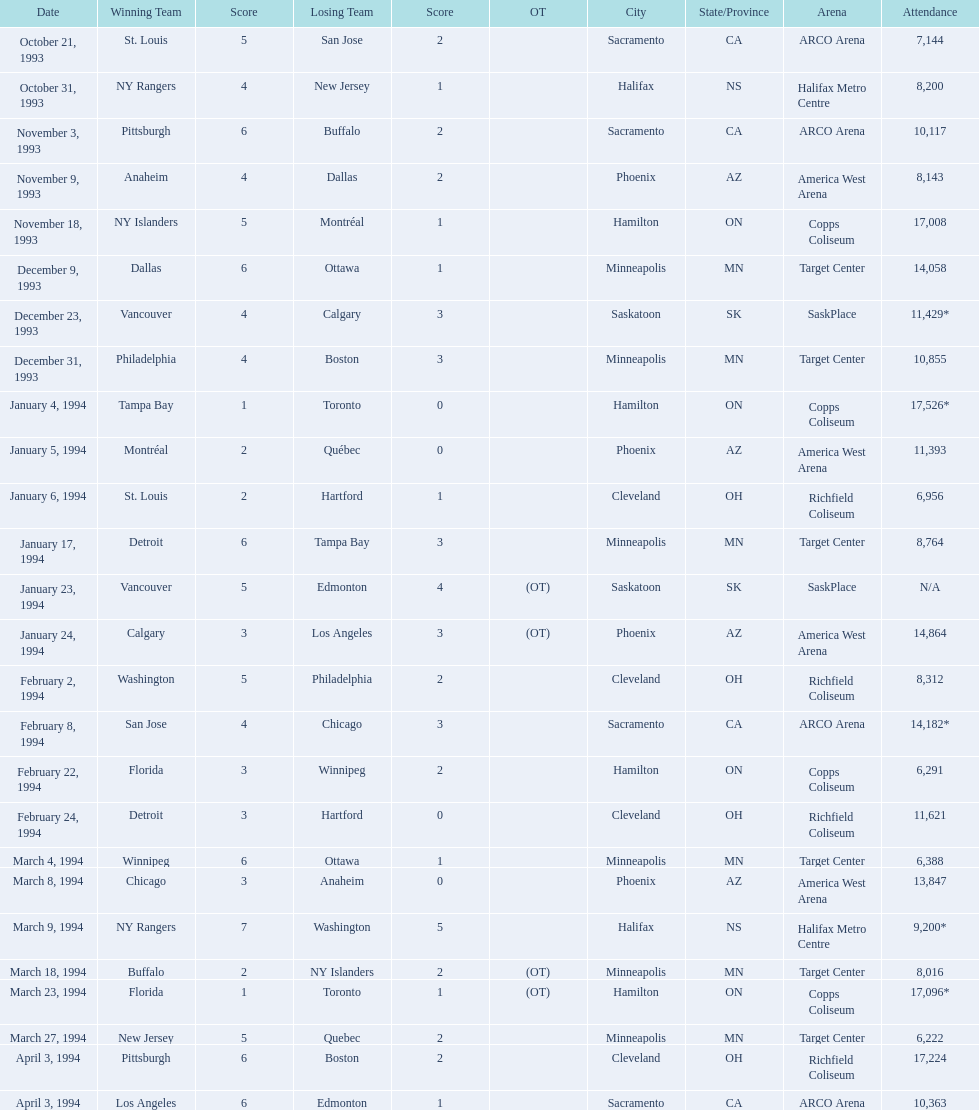How many individuals were in attendance on january 24, 1994? 14,864. What was the attendance count on december 23, 1993? 11,429*. Which of these two dates had a higher number of attendees? January 4, 1994. 